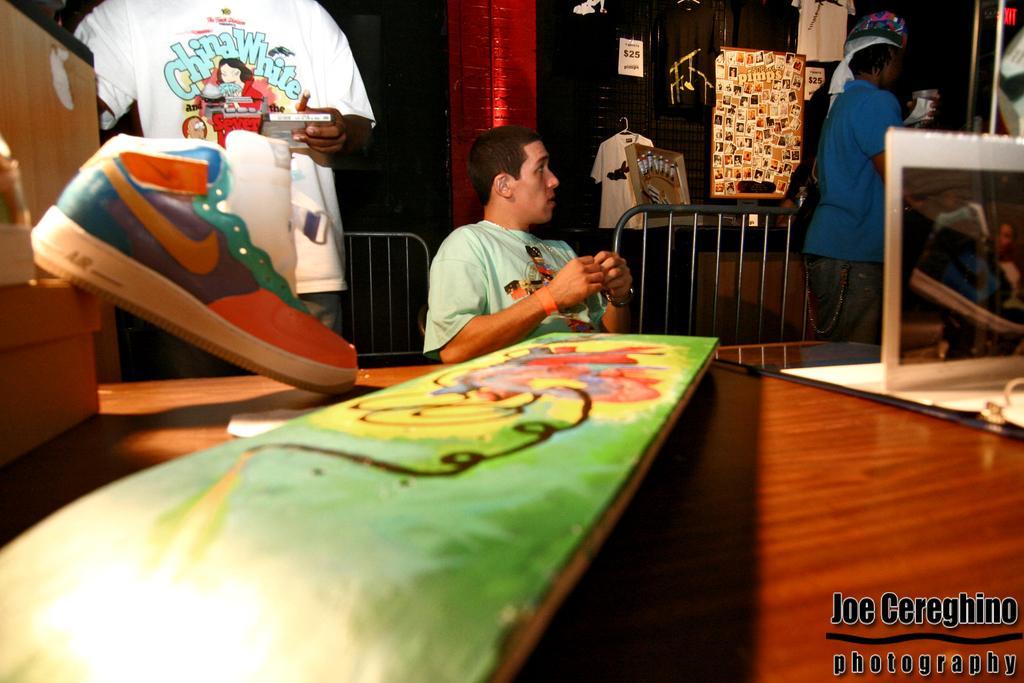Could you give a brief overview of what you see in this image? In the left side of the image, there is a person standing and holding an object. In the middle of the image, there is a person sitting on the bed. In the right top of the image, there is a person standing and holding an object. In the bottom of the image, there is a logo of Joe Caraghino Photography. This image is taken inside a shop. 